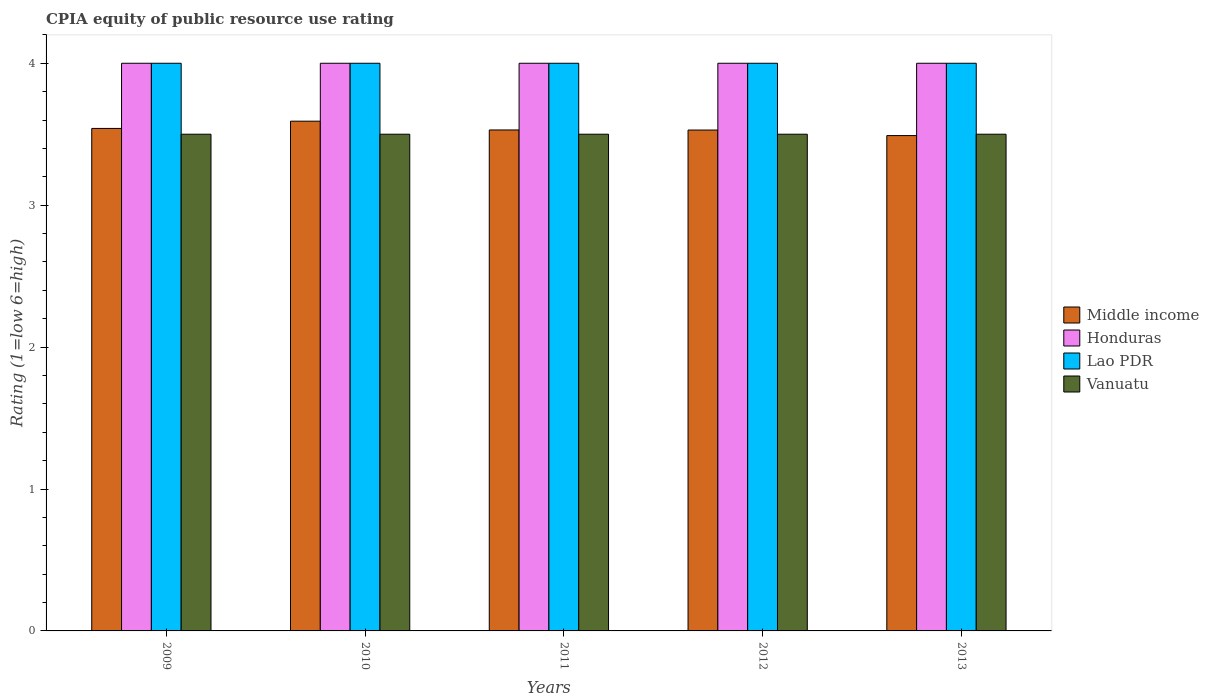How many groups of bars are there?
Ensure brevity in your answer.  5. Are the number of bars per tick equal to the number of legend labels?
Your answer should be compact. Yes. How many bars are there on the 4th tick from the right?
Your answer should be compact. 4. What is the label of the 5th group of bars from the left?
Make the answer very short. 2013. In how many cases, is the number of bars for a given year not equal to the number of legend labels?
Your response must be concise. 0. Across all years, what is the maximum CPIA rating in Middle income?
Keep it short and to the point. 3.59. Across all years, what is the minimum CPIA rating in Middle income?
Your response must be concise. 3.49. In which year was the CPIA rating in Middle income maximum?
Give a very brief answer. 2010. What is the total CPIA rating in Middle income in the graph?
Keep it short and to the point. 17.68. What is the difference between the CPIA rating in Middle income in 2009 and that in 2011?
Keep it short and to the point. 0.01. What is the average CPIA rating in Vanuatu per year?
Offer a very short reply. 3.5. In the year 2010, what is the difference between the CPIA rating in Lao PDR and CPIA rating in Middle income?
Your answer should be compact. 0.41. What is the ratio of the CPIA rating in Lao PDR in 2012 to that in 2013?
Ensure brevity in your answer.  1. Is the difference between the CPIA rating in Lao PDR in 2009 and 2012 greater than the difference between the CPIA rating in Middle income in 2009 and 2012?
Ensure brevity in your answer.  No. What is the difference between the highest and the second highest CPIA rating in Lao PDR?
Offer a very short reply. 0. What is the difference between the highest and the lowest CPIA rating in Honduras?
Ensure brevity in your answer.  0. In how many years, is the CPIA rating in Middle income greater than the average CPIA rating in Middle income taken over all years?
Provide a short and direct response. 2. Is it the case that in every year, the sum of the CPIA rating in Vanuatu and CPIA rating in Honduras is greater than the sum of CPIA rating in Middle income and CPIA rating in Lao PDR?
Offer a very short reply. Yes. What does the 2nd bar from the left in 2013 represents?
Give a very brief answer. Honduras. What does the 3rd bar from the right in 2013 represents?
Keep it short and to the point. Honduras. Is it the case that in every year, the sum of the CPIA rating in Middle income and CPIA rating in Lao PDR is greater than the CPIA rating in Vanuatu?
Offer a terse response. Yes. How many bars are there?
Provide a short and direct response. 20. Are all the bars in the graph horizontal?
Provide a succinct answer. No. What is the difference between two consecutive major ticks on the Y-axis?
Make the answer very short. 1. Are the values on the major ticks of Y-axis written in scientific E-notation?
Offer a terse response. No. Does the graph contain grids?
Make the answer very short. No. Where does the legend appear in the graph?
Ensure brevity in your answer.  Center right. What is the title of the graph?
Keep it short and to the point. CPIA equity of public resource use rating. What is the label or title of the X-axis?
Make the answer very short. Years. What is the label or title of the Y-axis?
Your answer should be very brief. Rating (1=low 6=high). What is the Rating (1=low 6=high) in Middle income in 2009?
Offer a terse response. 3.54. What is the Rating (1=low 6=high) of Honduras in 2009?
Your answer should be compact. 4. What is the Rating (1=low 6=high) in Lao PDR in 2009?
Give a very brief answer. 4. What is the Rating (1=low 6=high) of Vanuatu in 2009?
Your answer should be compact. 3.5. What is the Rating (1=low 6=high) in Middle income in 2010?
Make the answer very short. 3.59. What is the Rating (1=low 6=high) of Vanuatu in 2010?
Provide a short and direct response. 3.5. What is the Rating (1=low 6=high) in Middle income in 2011?
Ensure brevity in your answer.  3.53. What is the Rating (1=low 6=high) of Honduras in 2011?
Provide a short and direct response. 4. What is the Rating (1=low 6=high) of Lao PDR in 2011?
Offer a very short reply. 4. What is the Rating (1=low 6=high) of Middle income in 2012?
Your answer should be very brief. 3.53. What is the Rating (1=low 6=high) of Middle income in 2013?
Your answer should be very brief. 3.49. What is the Rating (1=low 6=high) of Honduras in 2013?
Keep it short and to the point. 4. Across all years, what is the maximum Rating (1=low 6=high) in Middle income?
Keep it short and to the point. 3.59. Across all years, what is the maximum Rating (1=low 6=high) in Vanuatu?
Offer a terse response. 3.5. Across all years, what is the minimum Rating (1=low 6=high) in Middle income?
Offer a very short reply. 3.49. What is the total Rating (1=low 6=high) in Middle income in the graph?
Your response must be concise. 17.68. What is the total Rating (1=low 6=high) in Lao PDR in the graph?
Your response must be concise. 20. What is the total Rating (1=low 6=high) of Vanuatu in the graph?
Ensure brevity in your answer.  17.5. What is the difference between the Rating (1=low 6=high) of Middle income in 2009 and that in 2010?
Offer a terse response. -0.05. What is the difference between the Rating (1=low 6=high) of Honduras in 2009 and that in 2010?
Give a very brief answer. 0. What is the difference between the Rating (1=low 6=high) in Lao PDR in 2009 and that in 2010?
Your answer should be very brief. 0. What is the difference between the Rating (1=low 6=high) in Vanuatu in 2009 and that in 2010?
Offer a very short reply. 0. What is the difference between the Rating (1=low 6=high) of Middle income in 2009 and that in 2011?
Your answer should be compact. 0.01. What is the difference between the Rating (1=low 6=high) in Honduras in 2009 and that in 2011?
Ensure brevity in your answer.  0. What is the difference between the Rating (1=low 6=high) of Lao PDR in 2009 and that in 2011?
Provide a succinct answer. 0. What is the difference between the Rating (1=low 6=high) in Vanuatu in 2009 and that in 2011?
Your response must be concise. 0. What is the difference between the Rating (1=low 6=high) of Middle income in 2009 and that in 2012?
Make the answer very short. 0.01. What is the difference between the Rating (1=low 6=high) of Vanuatu in 2009 and that in 2012?
Your response must be concise. 0. What is the difference between the Rating (1=low 6=high) of Middle income in 2009 and that in 2013?
Your answer should be very brief. 0.05. What is the difference between the Rating (1=low 6=high) of Middle income in 2010 and that in 2011?
Provide a succinct answer. 0.06. What is the difference between the Rating (1=low 6=high) in Lao PDR in 2010 and that in 2011?
Keep it short and to the point. 0. What is the difference between the Rating (1=low 6=high) in Vanuatu in 2010 and that in 2011?
Your answer should be very brief. 0. What is the difference between the Rating (1=low 6=high) of Middle income in 2010 and that in 2012?
Your answer should be very brief. 0.06. What is the difference between the Rating (1=low 6=high) in Vanuatu in 2010 and that in 2012?
Keep it short and to the point. 0. What is the difference between the Rating (1=low 6=high) in Middle income in 2010 and that in 2013?
Provide a succinct answer. 0.1. What is the difference between the Rating (1=low 6=high) in Honduras in 2010 and that in 2013?
Offer a terse response. 0. What is the difference between the Rating (1=low 6=high) of Lao PDR in 2010 and that in 2013?
Your answer should be very brief. 0. What is the difference between the Rating (1=low 6=high) of Middle income in 2011 and that in 2012?
Offer a terse response. 0. What is the difference between the Rating (1=low 6=high) in Honduras in 2011 and that in 2012?
Provide a short and direct response. 0. What is the difference between the Rating (1=low 6=high) in Middle income in 2011 and that in 2013?
Offer a terse response. 0.04. What is the difference between the Rating (1=low 6=high) of Honduras in 2011 and that in 2013?
Give a very brief answer. 0. What is the difference between the Rating (1=low 6=high) in Lao PDR in 2011 and that in 2013?
Give a very brief answer. 0. What is the difference between the Rating (1=low 6=high) in Middle income in 2012 and that in 2013?
Ensure brevity in your answer.  0.04. What is the difference between the Rating (1=low 6=high) in Middle income in 2009 and the Rating (1=low 6=high) in Honduras in 2010?
Your answer should be very brief. -0.46. What is the difference between the Rating (1=low 6=high) of Middle income in 2009 and the Rating (1=low 6=high) of Lao PDR in 2010?
Offer a very short reply. -0.46. What is the difference between the Rating (1=low 6=high) in Middle income in 2009 and the Rating (1=low 6=high) in Vanuatu in 2010?
Your response must be concise. 0.04. What is the difference between the Rating (1=low 6=high) in Honduras in 2009 and the Rating (1=low 6=high) in Vanuatu in 2010?
Provide a succinct answer. 0.5. What is the difference between the Rating (1=low 6=high) of Middle income in 2009 and the Rating (1=low 6=high) of Honduras in 2011?
Your answer should be very brief. -0.46. What is the difference between the Rating (1=low 6=high) of Middle income in 2009 and the Rating (1=low 6=high) of Lao PDR in 2011?
Make the answer very short. -0.46. What is the difference between the Rating (1=low 6=high) of Middle income in 2009 and the Rating (1=low 6=high) of Vanuatu in 2011?
Your answer should be very brief. 0.04. What is the difference between the Rating (1=low 6=high) in Middle income in 2009 and the Rating (1=low 6=high) in Honduras in 2012?
Ensure brevity in your answer.  -0.46. What is the difference between the Rating (1=low 6=high) of Middle income in 2009 and the Rating (1=low 6=high) of Lao PDR in 2012?
Your answer should be compact. -0.46. What is the difference between the Rating (1=low 6=high) of Middle income in 2009 and the Rating (1=low 6=high) of Vanuatu in 2012?
Your answer should be very brief. 0.04. What is the difference between the Rating (1=low 6=high) of Lao PDR in 2009 and the Rating (1=low 6=high) of Vanuatu in 2012?
Your response must be concise. 0.5. What is the difference between the Rating (1=low 6=high) of Middle income in 2009 and the Rating (1=low 6=high) of Honduras in 2013?
Provide a short and direct response. -0.46. What is the difference between the Rating (1=low 6=high) of Middle income in 2009 and the Rating (1=low 6=high) of Lao PDR in 2013?
Provide a short and direct response. -0.46. What is the difference between the Rating (1=low 6=high) of Middle income in 2009 and the Rating (1=low 6=high) of Vanuatu in 2013?
Give a very brief answer. 0.04. What is the difference between the Rating (1=low 6=high) in Honduras in 2009 and the Rating (1=low 6=high) in Vanuatu in 2013?
Keep it short and to the point. 0.5. What is the difference between the Rating (1=low 6=high) of Middle income in 2010 and the Rating (1=low 6=high) of Honduras in 2011?
Your response must be concise. -0.41. What is the difference between the Rating (1=low 6=high) in Middle income in 2010 and the Rating (1=low 6=high) in Lao PDR in 2011?
Your response must be concise. -0.41. What is the difference between the Rating (1=low 6=high) in Middle income in 2010 and the Rating (1=low 6=high) in Vanuatu in 2011?
Your response must be concise. 0.09. What is the difference between the Rating (1=low 6=high) in Honduras in 2010 and the Rating (1=low 6=high) in Lao PDR in 2011?
Ensure brevity in your answer.  0. What is the difference between the Rating (1=low 6=high) in Honduras in 2010 and the Rating (1=low 6=high) in Vanuatu in 2011?
Your answer should be compact. 0.5. What is the difference between the Rating (1=low 6=high) of Middle income in 2010 and the Rating (1=low 6=high) of Honduras in 2012?
Provide a succinct answer. -0.41. What is the difference between the Rating (1=low 6=high) in Middle income in 2010 and the Rating (1=low 6=high) in Lao PDR in 2012?
Your response must be concise. -0.41. What is the difference between the Rating (1=low 6=high) in Middle income in 2010 and the Rating (1=low 6=high) in Vanuatu in 2012?
Give a very brief answer. 0.09. What is the difference between the Rating (1=low 6=high) in Honduras in 2010 and the Rating (1=low 6=high) in Lao PDR in 2012?
Ensure brevity in your answer.  0. What is the difference between the Rating (1=low 6=high) of Honduras in 2010 and the Rating (1=low 6=high) of Vanuatu in 2012?
Make the answer very short. 0.5. What is the difference between the Rating (1=low 6=high) of Middle income in 2010 and the Rating (1=low 6=high) of Honduras in 2013?
Keep it short and to the point. -0.41. What is the difference between the Rating (1=low 6=high) in Middle income in 2010 and the Rating (1=low 6=high) in Lao PDR in 2013?
Your answer should be very brief. -0.41. What is the difference between the Rating (1=low 6=high) of Middle income in 2010 and the Rating (1=low 6=high) of Vanuatu in 2013?
Give a very brief answer. 0.09. What is the difference between the Rating (1=low 6=high) in Middle income in 2011 and the Rating (1=low 6=high) in Honduras in 2012?
Your answer should be very brief. -0.47. What is the difference between the Rating (1=low 6=high) in Middle income in 2011 and the Rating (1=low 6=high) in Lao PDR in 2012?
Ensure brevity in your answer.  -0.47. What is the difference between the Rating (1=low 6=high) in Honduras in 2011 and the Rating (1=low 6=high) in Lao PDR in 2012?
Your answer should be compact. 0. What is the difference between the Rating (1=low 6=high) in Honduras in 2011 and the Rating (1=low 6=high) in Vanuatu in 2012?
Make the answer very short. 0.5. What is the difference between the Rating (1=low 6=high) of Middle income in 2011 and the Rating (1=low 6=high) of Honduras in 2013?
Keep it short and to the point. -0.47. What is the difference between the Rating (1=low 6=high) in Middle income in 2011 and the Rating (1=low 6=high) in Lao PDR in 2013?
Make the answer very short. -0.47. What is the difference between the Rating (1=low 6=high) of Honduras in 2011 and the Rating (1=low 6=high) of Vanuatu in 2013?
Offer a very short reply. 0.5. What is the difference between the Rating (1=low 6=high) in Lao PDR in 2011 and the Rating (1=low 6=high) in Vanuatu in 2013?
Your answer should be very brief. 0.5. What is the difference between the Rating (1=low 6=high) in Middle income in 2012 and the Rating (1=low 6=high) in Honduras in 2013?
Give a very brief answer. -0.47. What is the difference between the Rating (1=low 6=high) of Middle income in 2012 and the Rating (1=low 6=high) of Lao PDR in 2013?
Your answer should be very brief. -0.47. What is the difference between the Rating (1=low 6=high) in Middle income in 2012 and the Rating (1=low 6=high) in Vanuatu in 2013?
Give a very brief answer. 0.03. What is the difference between the Rating (1=low 6=high) in Honduras in 2012 and the Rating (1=low 6=high) in Lao PDR in 2013?
Make the answer very short. 0. What is the difference between the Rating (1=low 6=high) in Honduras in 2012 and the Rating (1=low 6=high) in Vanuatu in 2013?
Your answer should be very brief. 0.5. What is the average Rating (1=low 6=high) of Middle income per year?
Keep it short and to the point. 3.54. What is the average Rating (1=low 6=high) of Lao PDR per year?
Keep it short and to the point. 4. What is the average Rating (1=low 6=high) in Vanuatu per year?
Make the answer very short. 3.5. In the year 2009, what is the difference between the Rating (1=low 6=high) of Middle income and Rating (1=low 6=high) of Honduras?
Provide a succinct answer. -0.46. In the year 2009, what is the difference between the Rating (1=low 6=high) of Middle income and Rating (1=low 6=high) of Lao PDR?
Offer a terse response. -0.46. In the year 2009, what is the difference between the Rating (1=low 6=high) in Middle income and Rating (1=low 6=high) in Vanuatu?
Ensure brevity in your answer.  0.04. In the year 2009, what is the difference between the Rating (1=low 6=high) of Lao PDR and Rating (1=low 6=high) of Vanuatu?
Provide a succinct answer. 0.5. In the year 2010, what is the difference between the Rating (1=low 6=high) in Middle income and Rating (1=low 6=high) in Honduras?
Offer a terse response. -0.41. In the year 2010, what is the difference between the Rating (1=low 6=high) of Middle income and Rating (1=low 6=high) of Lao PDR?
Provide a short and direct response. -0.41. In the year 2010, what is the difference between the Rating (1=low 6=high) of Middle income and Rating (1=low 6=high) of Vanuatu?
Offer a terse response. 0.09. In the year 2010, what is the difference between the Rating (1=low 6=high) in Honduras and Rating (1=low 6=high) in Lao PDR?
Your response must be concise. 0. In the year 2011, what is the difference between the Rating (1=low 6=high) in Middle income and Rating (1=low 6=high) in Honduras?
Keep it short and to the point. -0.47. In the year 2011, what is the difference between the Rating (1=low 6=high) of Middle income and Rating (1=low 6=high) of Lao PDR?
Provide a succinct answer. -0.47. In the year 2011, what is the difference between the Rating (1=low 6=high) of Middle income and Rating (1=low 6=high) of Vanuatu?
Your answer should be compact. 0.03. In the year 2011, what is the difference between the Rating (1=low 6=high) of Honduras and Rating (1=low 6=high) of Lao PDR?
Your answer should be very brief. 0. In the year 2011, what is the difference between the Rating (1=low 6=high) of Lao PDR and Rating (1=low 6=high) of Vanuatu?
Give a very brief answer. 0.5. In the year 2012, what is the difference between the Rating (1=low 6=high) of Middle income and Rating (1=low 6=high) of Honduras?
Your answer should be very brief. -0.47. In the year 2012, what is the difference between the Rating (1=low 6=high) of Middle income and Rating (1=low 6=high) of Lao PDR?
Keep it short and to the point. -0.47. In the year 2012, what is the difference between the Rating (1=low 6=high) in Middle income and Rating (1=low 6=high) in Vanuatu?
Make the answer very short. 0.03. In the year 2012, what is the difference between the Rating (1=low 6=high) in Honduras and Rating (1=low 6=high) in Lao PDR?
Your response must be concise. 0. In the year 2013, what is the difference between the Rating (1=low 6=high) of Middle income and Rating (1=low 6=high) of Honduras?
Provide a short and direct response. -0.51. In the year 2013, what is the difference between the Rating (1=low 6=high) of Middle income and Rating (1=low 6=high) of Lao PDR?
Your answer should be very brief. -0.51. In the year 2013, what is the difference between the Rating (1=low 6=high) in Middle income and Rating (1=low 6=high) in Vanuatu?
Provide a short and direct response. -0.01. What is the ratio of the Rating (1=low 6=high) in Middle income in 2009 to that in 2010?
Keep it short and to the point. 0.99. What is the ratio of the Rating (1=low 6=high) in Honduras in 2009 to that in 2010?
Provide a succinct answer. 1. What is the ratio of the Rating (1=low 6=high) in Vanuatu in 2009 to that in 2010?
Your answer should be compact. 1. What is the ratio of the Rating (1=low 6=high) in Lao PDR in 2009 to that in 2011?
Your answer should be very brief. 1. What is the ratio of the Rating (1=low 6=high) in Middle income in 2009 to that in 2012?
Provide a short and direct response. 1. What is the ratio of the Rating (1=low 6=high) of Honduras in 2009 to that in 2012?
Make the answer very short. 1. What is the ratio of the Rating (1=low 6=high) in Middle income in 2009 to that in 2013?
Keep it short and to the point. 1.01. What is the ratio of the Rating (1=low 6=high) of Honduras in 2009 to that in 2013?
Give a very brief answer. 1. What is the ratio of the Rating (1=low 6=high) of Middle income in 2010 to that in 2011?
Your response must be concise. 1.02. What is the ratio of the Rating (1=low 6=high) in Honduras in 2010 to that in 2011?
Provide a short and direct response. 1. What is the ratio of the Rating (1=low 6=high) in Vanuatu in 2010 to that in 2011?
Offer a terse response. 1. What is the ratio of the Rating (1=low 6=high) in Middle income in 2010 to that in 2012?
Offer a terse response. 1.02. What is the ratio of the Rating (1=low 6=high) of Lao PDR in 2010 to that in 2012?
Provide a short and direct response. 1. What is the ratio of the Rating (1=low 6=high) of Middle income in 2010 to that in 2013?
Give a very brief answer. 1.03. What is the ratio of the Rating (1=low 6=high) of Lao PDR in 2011 to that in 2012?
Offer a terse response. 1. What is the ratio of the Rating (1=low 6=high) in Vanuatu in 2011 to that in 2012?
Keep it short and to the point. 1. What is the ratio of the Rating (1=low 6=high) in Middle income in 2011 to that in 2013?
Ensure brevity in your answer.  1.01. What is the ratio of the Rating (1=low 6=high) of Honduras in 2011 to that in 2013?
Your answer should be compact. 1. What is the ratio of the Rating (1=low 6=high) in Middle income in 2012 to that in 2013?
Your answer should be compact. 1.01. What is the ratio of the Rating (1=low 6=high) in Lao PDR in 2012 to that in 2013?
Your response must be concise. 1. What is the difference between the highest and the second highest Rating (1=low 6=high) of Middle income?
Offer a very short reply. 0.05. What is the difference between the highest and the second highest Rating (1=low 6=high) in Lao PDR?
Your response must be concise. 0. What is the difference between the highest and the second highest Rating (1=low 6=high) in Vanuatu?
Your answer should be very brief. 0. What is the difference between the highest and the lowest Rating (1=low 6=high) in Middle income?
Make the answer very short. 0.1. What is the difference between the highest and the lowest Rating (1=low 6=high) in Honduras?
Keep it short and to the point. 0. 